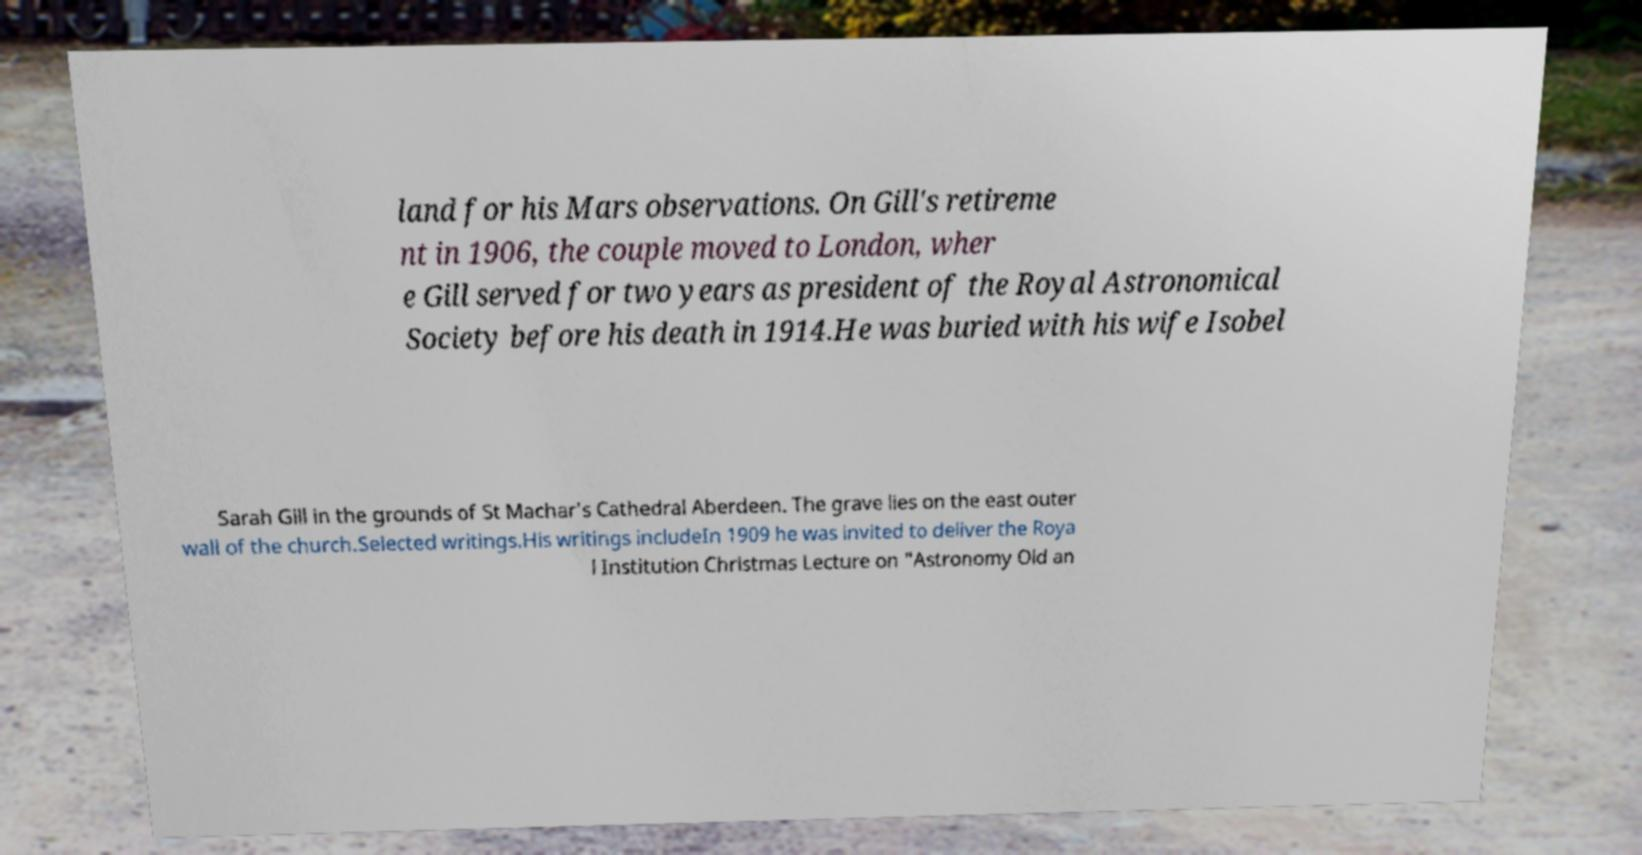Please read and relay the text visible in this image. What does it say? land for his Mars observations. On Gill's retireme nt in 1906, the couple moved to London, wher e Gill served for two years as president of the Royal Astronomical Society before his death in 1914.He was buried with his wife Isobel Sarah Gill in the grounds of St Machar's Cathedral Aberdeen. The grave lies on the east outer wall of the church.Selected writings.His writings includeIn 1909 he was invited to deliver the Roya l Institution Christmas Lecture on "Astronomy Old an 